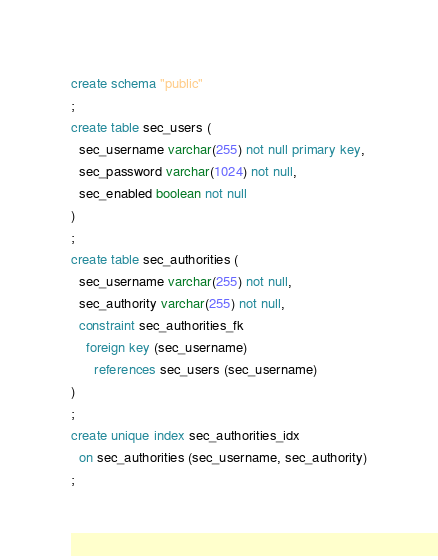Convert code to text. <code><loc_0><loc_0><loc_500><loc_500><_SQL_>create schema "public"
;
create table sec_users (
  sec_username varchar(255) not null primary key,
  sec_password varchar(1024) not null,
  sec_enabled boolean not null
)
;
create table sec_authorities (
  sec_username varchar(255) not null,
  sec_authority varchar(255) not null,
  constraint sec_authorities_fk
    foreign key (sec_username)
      references sec_users (sec_username)
)
;
create unique index sec_authorities_idx
  on sec_authorities (sec_username, sec_authority)
;
</code> 